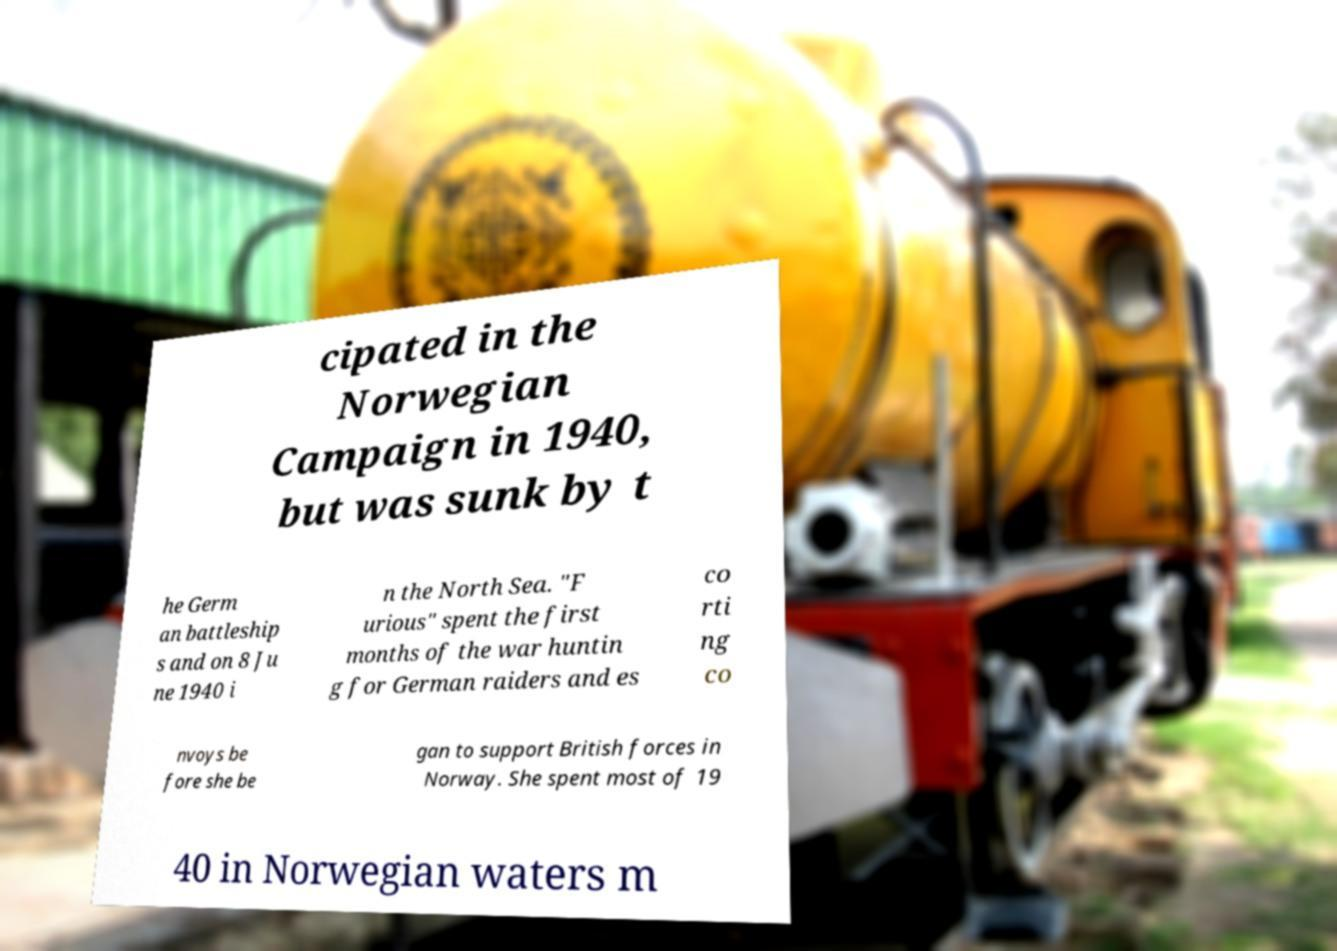Please read and relay the text visible in this image. What does it say? cipated in the Norwegian Campaign in 1940, but was sunk by t he Germ an battleship s and on 8 Ju ne 1940 i n the North Sea. "F urious" spent the first months of the war huntin g for German raiders and es co rti ng co nvoys be fore she be gan to support British forces in Norway. She spent most of 19 40 in Norwegian waters m 